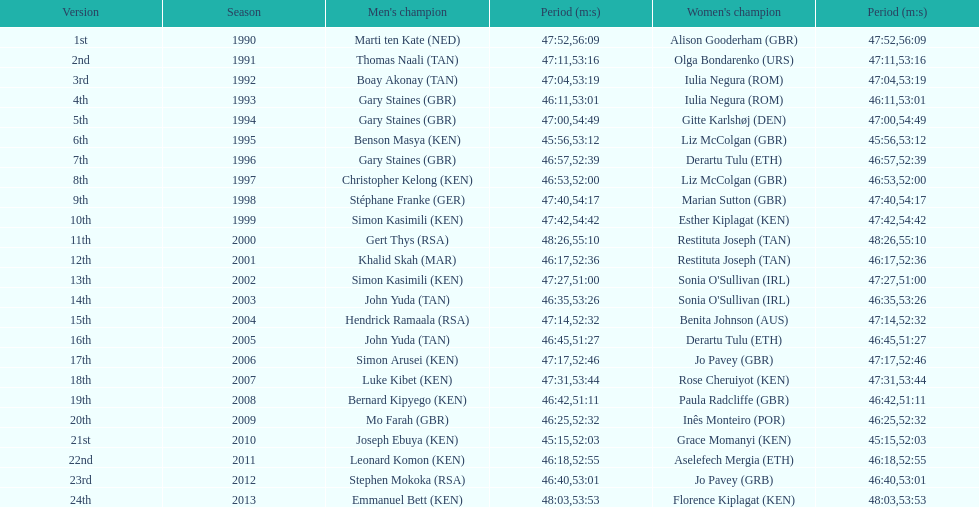The other women's winner with the same finish time as jo pavey in 2012 Iulia Negura. 